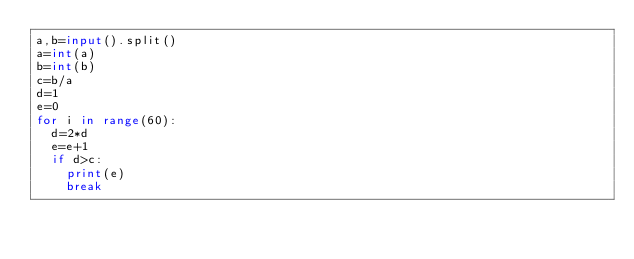Convert code to text. <code><loc_0><loc_0><loc_500><loc_500><_Python_>a,b=input().split()
a=int(a)
b=int(b)
c=b/a
d=1
e=0
for i in range(60):
  d=2*d
  e=e+1
  if d>c:
    print(e)
    break</code> 